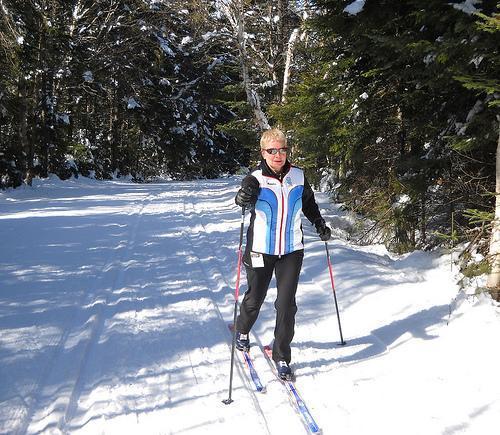How many skis does she have?
Give a very brief answer. 2. 